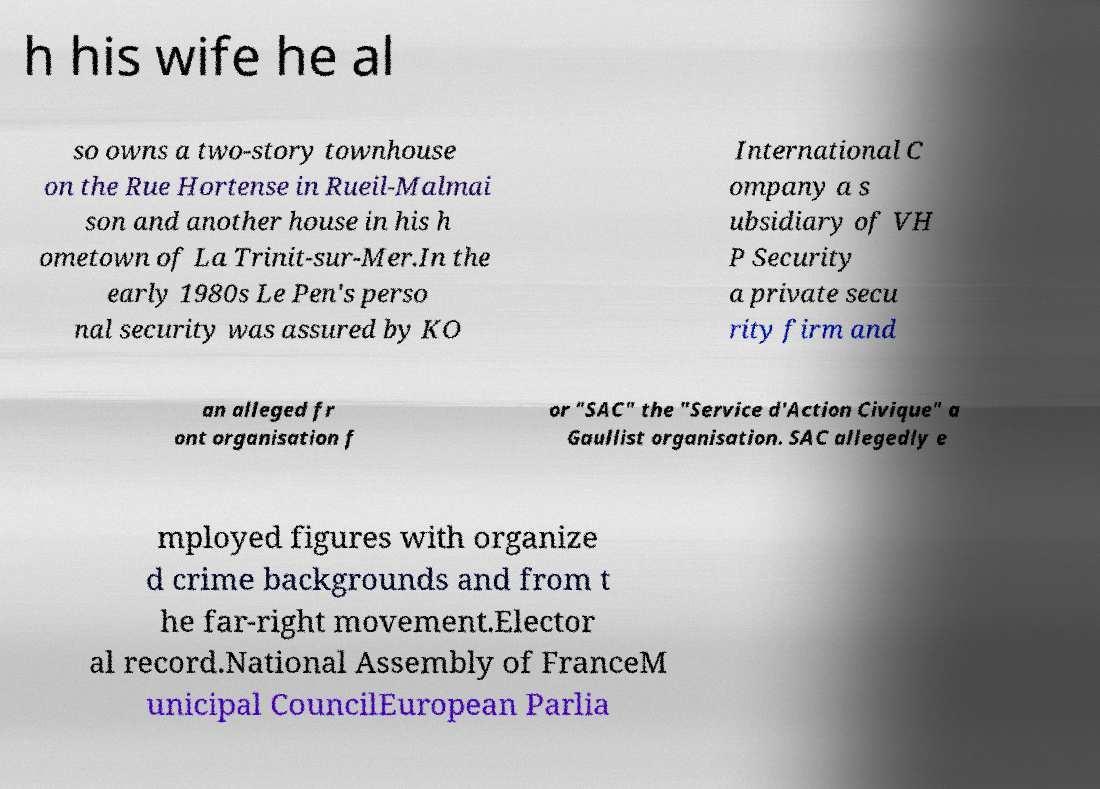What messages or text are displayed in this image? I need them in a readable, typed format. h his wife he al so owns a two-story townhouse on the Rue Hortense in Rueil-Malmai son and another house in his h ometown of La Trinit-sur-Mer.In the early 1980s Le Pen's perso nal security was assured by KO International C ompany a s ubsidiary of VH P Security a private secu rity firm and an alleged fr ont organisation f or "SAC" the "Service d'Action Civique" a Gaullist organisation. SAC allegedly e mployed figures with organize d crime backgrounds and from t he far-right movement.Elector al record.National Assembly of FranceM unicipal CouncilEuropean Parlia 